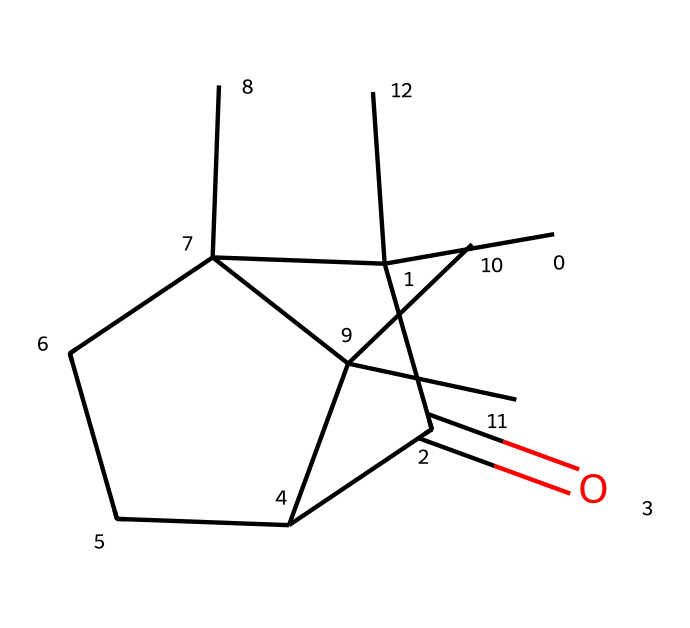What is the chemical name of this structure? The SMILES provided corresponds to a known compound, where "CC1" indicates a specific carbon structure that can be identified as camphor, a natural ketone.
Answer: camphor How many rings are present in the structure? By analyzing the SMILES, there are two instances of "C" that initiate rings (C1 and C2), indicating the presence of two ring structures in camphor.
Answer: 2 What functional group is present in camphor? The "=O" in the SMILES notation indicates the presence of a carbonyl functional group, which is characteristic of ketones.
Answer: carbonyl What is the total number of carbon atoms in camphor? Counting the carbon atoms represented in the SMILES notation "CC1(C(=O)C2CCC1(C)C2(C)C)", there are a total of 10 carbon atoms in camphor.
Answer: 10 Does camphor have a chiral center? The presence of a carbon atom attached to four different substituents (like in the 1st carbon of the ring) indicates that there is a chiral center in the structure of camphor.
Answer: Yes Is camphor a solid, liquid, or gas at room temperature? Camphor is commonly known to be a solid at room temperature, which corresponds with its common medicinal use.
Answer: solid 